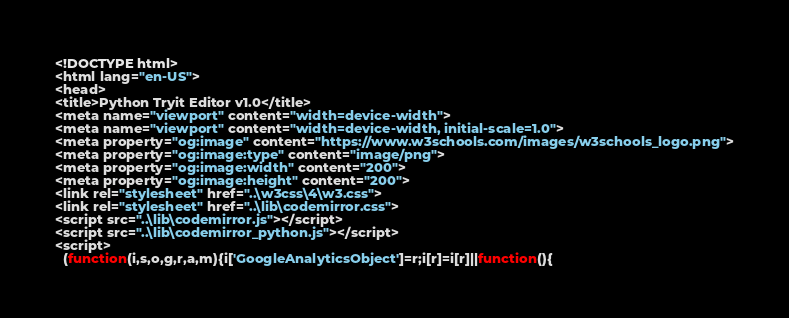Convert code to text. <code><loc_0><loc_0><loc_500><loc_500><_HTML_>
<!DOCTYPE html>
<html lang="en-US">
<head>
<title>Python Tryit Editor v1.0</title>
<meta name="viewport" content="width=device-width">
<meta name="viewport" content="width=device-width, initial-scale=1.0">
<meta property="og:image" content="https://www.w3schools.com/images/w3schools_logo.png">
<meta property="og:image:type" content="image/png">
<meta property="og:image:width" content="200">
<meta property="og:image:height" content="200">
<link rel="stylesheet" href="..\w3css\4\w3.css">
<link rel="stylesheet" href="..\lib\codemirror.css">
<script src="..\lib\codemirror.js"></script>
<script src="..\lib\codemirror_python.js"></script>
<script>
  (function(i,s,o,g,r,a,m){i['GoogleAnalyticsObject']=r;i[r]=i[r]||function(){</code> 